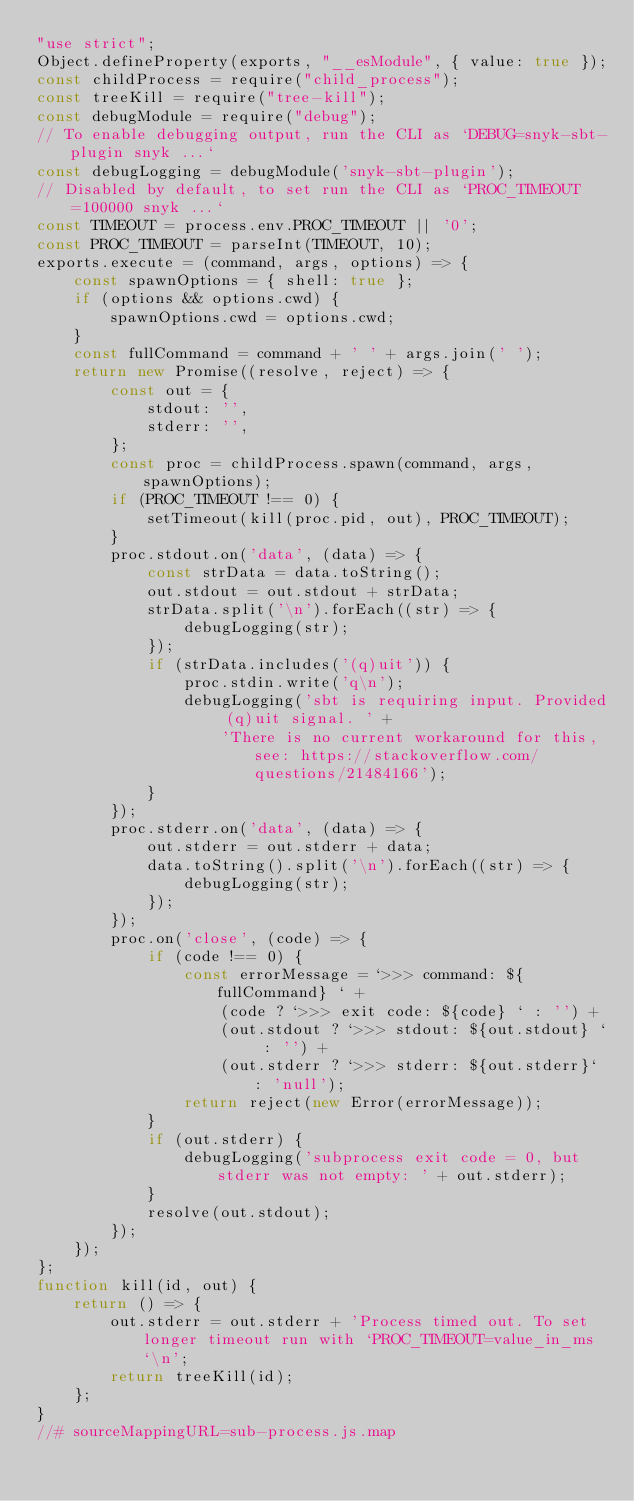Convert code to text. <code><loc_0><loc_0><loc_500><loc_500><_JavaScript_>"use strict";
Object.defineProperty(exports, "__esModule", { value: true });
const childProcess = require("child_process");
const treeKill = require("tree-kill");
const debugModule = require("debug");
// To enable debugging output, run the CLI as `DEBUG=snyk-sbt-plugin snyk ...`
const debugLogging = debugModule('snyk-sbt-plugin');
// Disabled by default, to set run the CLI as `PROC_TIMEOUT=100000 snyk ...`
const TIMEOUT = process.env.PROC_TIMEOUT || '0';
const PROC_TIMEOUT = parseInt(TIMEOUT, 10);
exports.execute = (command, args, options) => {
    const spawnOptions = { shell: true };
    if (options && options.cwd) {
        spawnOptions.cwd = options.cwd;
    }
    const fullCommand = command + ' ' + args.join(' ');
    return new Promise((resolve, reject) => {
        const out = {
            stdout: '',
            stderr: '',
        };
        const proc = childProcess.spawn(command, args, spawnOptions);
        if (PROC_TIMEOUT !== 0) {
            setTimeout(kill(proc.pid, out), PROC_TIMEOUT);
        }
        proc.stdout.on('data', (data) => {
            const strData = data.toString();
            out.stdout = out.stdout + strData;
            strData.split('\n').forEach((str) => {
                debugLogging(str);
            });
            if (strData.includes('(q)uit')) {
                proc.stdin.write('q\n');
                debugLogging('sbt is requiring input. Provided (q)uit signal. ' +
                    'There is no current workaround for this, see: https://stackoverflow.com/questions/21484166');
            }
        });
        proc.stderr.on('data', (data) => {
            out.stderr = out.stderr + data;
            data.toString().split('\n').forEach((str) => {
                debugLogging(str);
            });
        });
        proc.on('close', (code) => {
            if (code !== 0) {
                const errorMessage = `>>> command: ${fullCommand} ` +
                    (code ? `>>> exit code: ${code} ` : '') +
                    (out.stdout ? `>>> stdout: ${out.stdout} ` : '') +
                    (out.stderr ? `>>> stderr: ${out.stderr}` : 'null');
                return reject(new Error(errorMessage));
            }
            if (out.stderr) {
                debugLogging('subprocess exit code = 0, but stderr was not empty: ' + out.stderr);
            }
            resolve(out.stdout);
        });
    });
};
function kill(id, out) {
    return () => {
        out.stderr = out.stderr + 'Process timed out. To set longer timeout run with `PROC_TIMEOUT=value_in_ms`\n';
        return treeKill(id);
    };
}
//# sourceMappingURL=sub-process.js.map</code> 